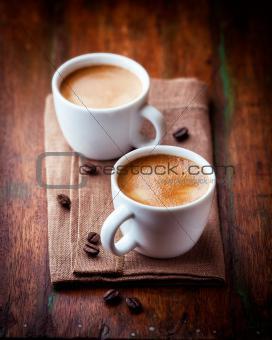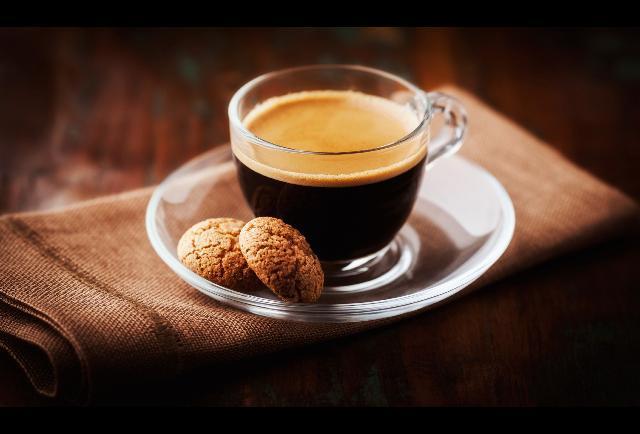The first image is the image on the left, the second image is the image on the right. Analyze the images presented: Is the assertion "A pair of white cups sit on a folded woven beige cloth with a scattering of coffee beans on it." valid? Answer yes or no. Yes. 